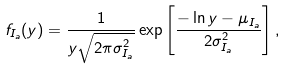<formula> <loc_0><loc_0><loc_500><loc_500>f _ { I _ { a } } ( y ) = \frac { 1 } { y \sqrt { 2 \pi \sigma _ { I _ { a } } ^ { 2 } } } \exp \left [ \frac { - \ln y - \mu _ { I _ { a } } } { 2 \sigma _ { I _ { a } } ^ { 2 } } \right ] ,</formula> 